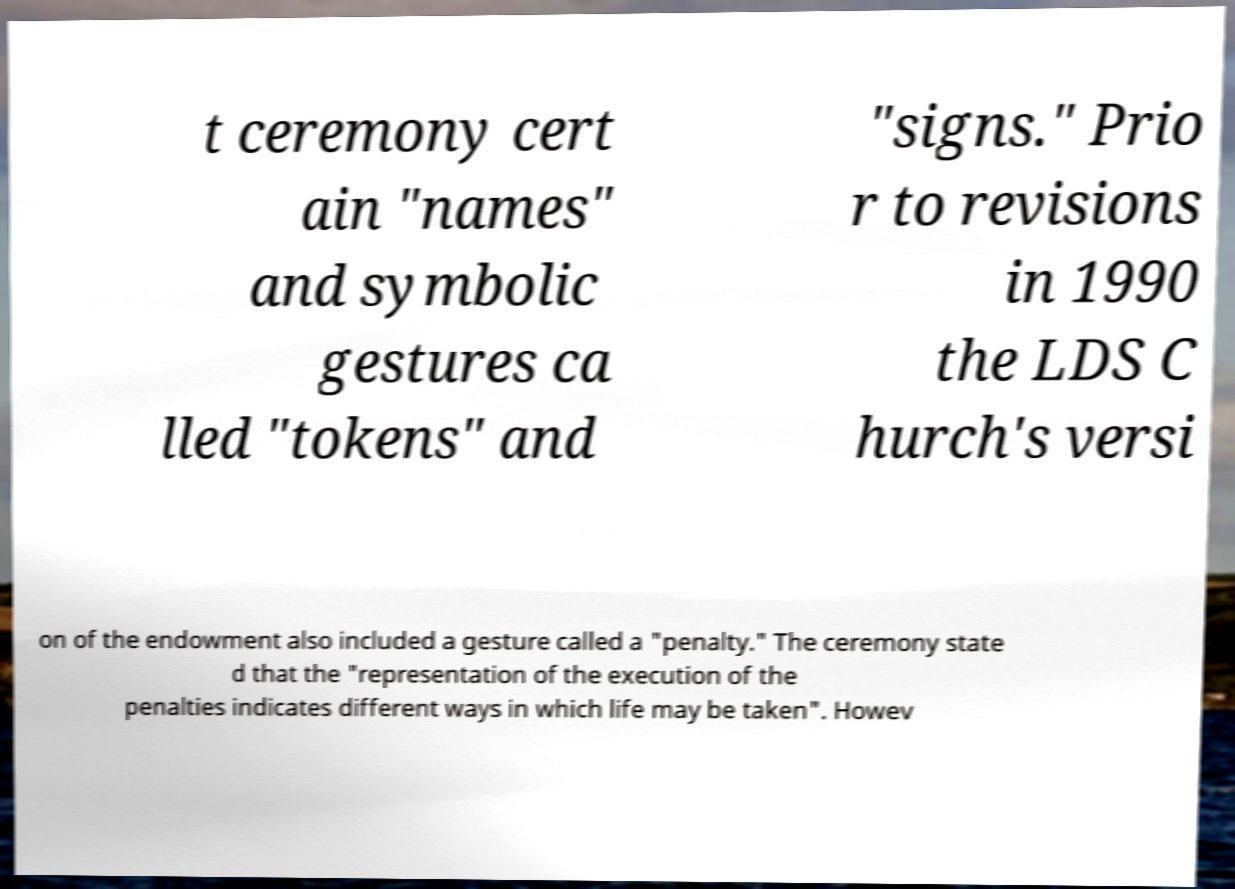Can you read and provide the text displayed in the image?This photo seems to have some interesting text. Can you extract and type it out for me? t ceremony cert ain "names" and symbolic gestures ca lled "tokens" and "signs." Prio r to revisions in 1990 the LDS C hurch's versi on of the endowment also included a gesture called a "penalty." The ceremony state d that the "representation of the execution of the penalties indicates different ways in which life may be taken". Howev 